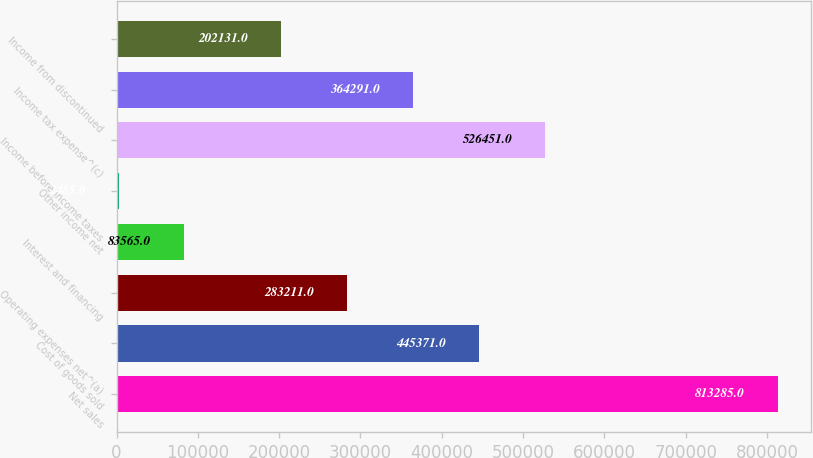Convert chart. <chart><loc_0><loc_0><loc_500><loc_500><bar_chart><fcel>Net sales<fcel>Cost of goods sold<fcel>Operating expenses net^(a)<fcel>Interest and financing<fcel>Other income net<fcel>Income before income taxes<fcel>Income tax expense^(c)<fcel>Income from discontinued<nl><fcel>813285<fcel>445371<fcel>283211<fcel>83565<fcel>2485<fcel>526451<fcel>364291<fcel>202131<nl></chart> 